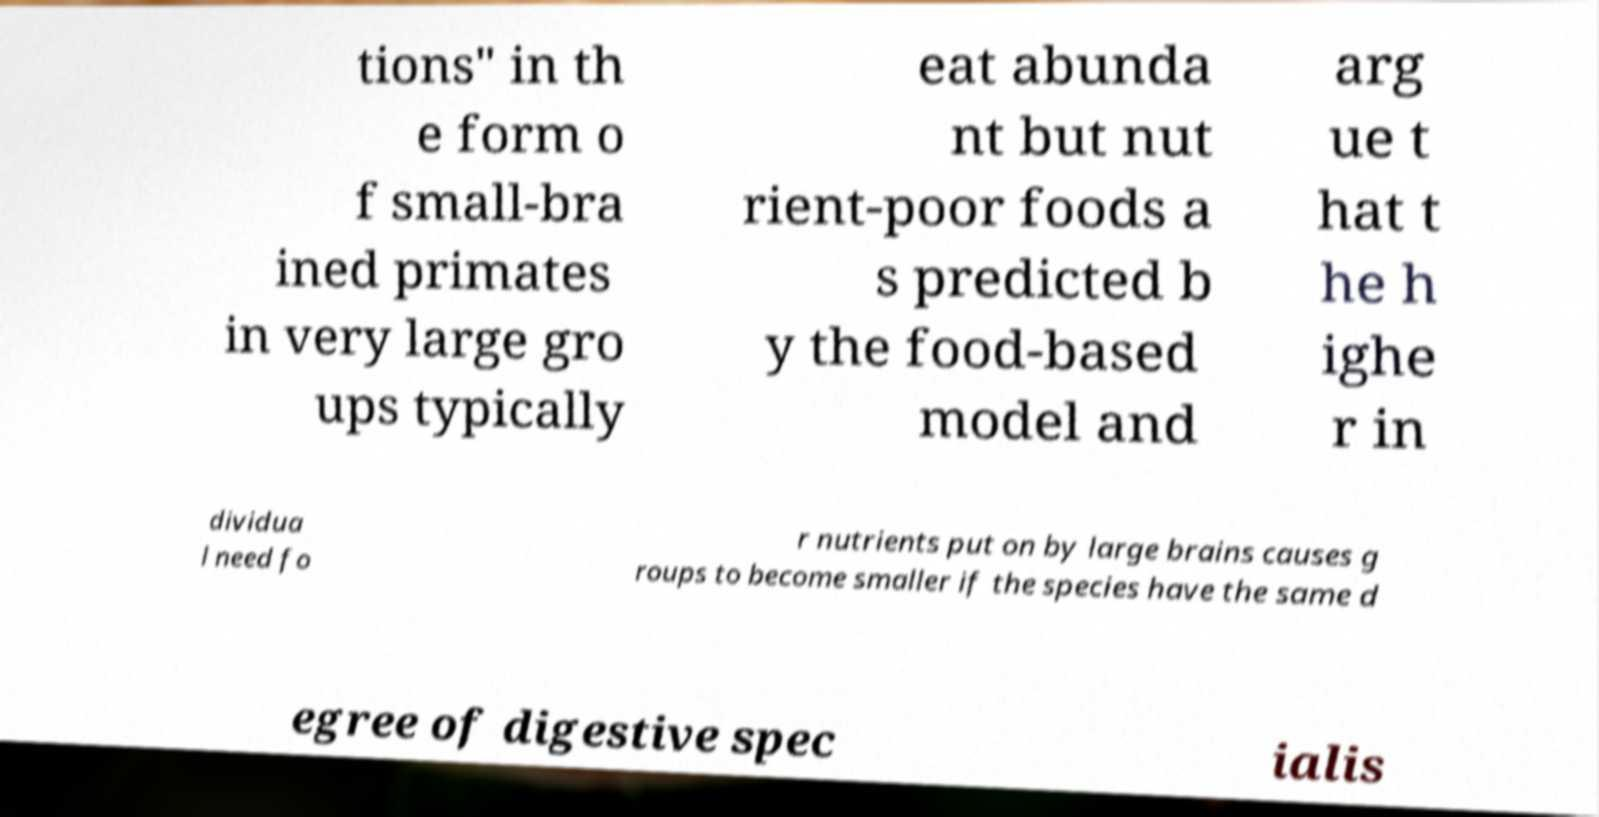There's text embedded in this image that I need extracted. Can you transcribe it verbatim? tions" in th e form o f small-bra ined primates in very large gro ups typically eat abunda nt but nut rient-poor foods a s predicted b y the food-based model and arg ue t hat t he h ighe r in dividua l need fo r nutrients put on by large brains causes g roups to become smaller if the species have the same d egree of digestive spec ialis 